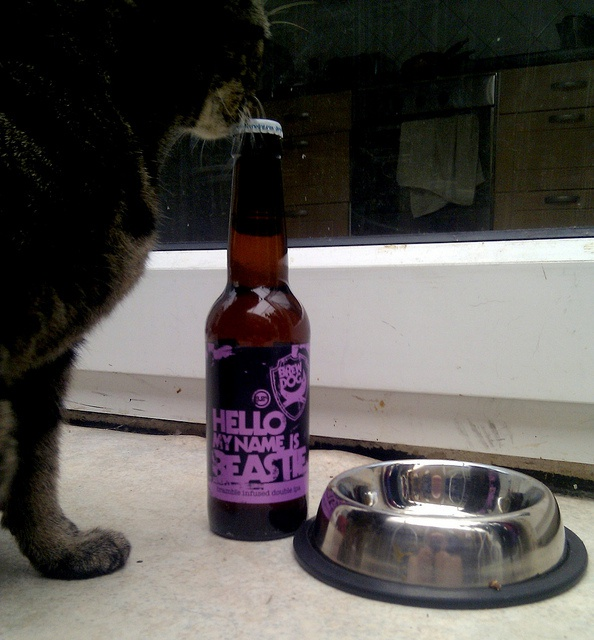Describe the objects in this image and their specific colors. I can see cat in black, gray, and darkgray tones, bottle in black and purple tones, and bowl in black, gray, darkgray, and white tones in this image. 